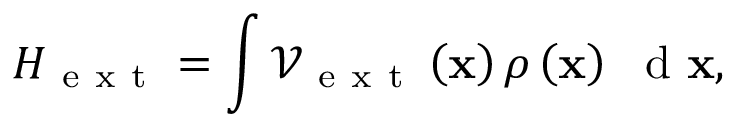Convert formula to latex. <formula><loc_0><loc_0><loc_500><loc_500>H _ { e x t } = \int { \mathcal { V } _ { e x t } \left ( { x } \right ) \rho \left ( { x } \right ) \ d { x } } ,</formula> 